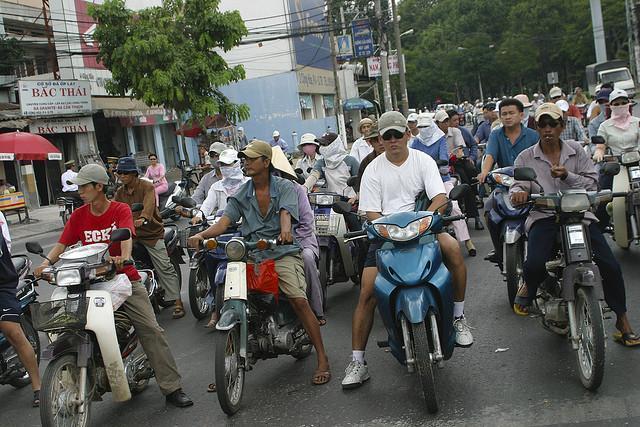What type of area is shown?
Choose the right answer from the provided options to respond to the question.
Options: Coastal, rural, urban, forest. Urban. 